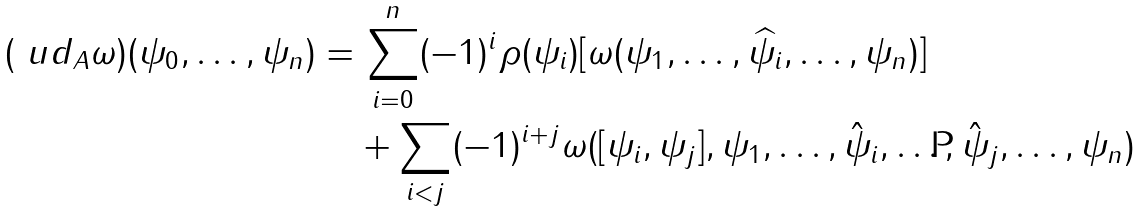<formula> <loc_0><loc_0><loc_500><loc_500>( \ u d _ { A } \omega ) ( \psi _ { 0 } , \dots , \psi _ { n } ) = & \, \sum _ { i = 0 } ^ { n } ( - 1 ) ^ { i } \rho ( \psi _ { i } ) [ \omega ( \psi _ { 1 } , \dots , \widehat { \psi _ { i } } , \dots , \psi _ { n } ) ] \\ & + \sum _ { i < j } ( - 1 ) ^ { i + j } \omega ( [ \psi _ { i } , \psi _ { j } ] , \psi _ { 1 } , \dots , \hat { \psi } _ { i } , \dots , \hat { \psi } _ { j } , \dots , \psi _ { n } )</formula> 